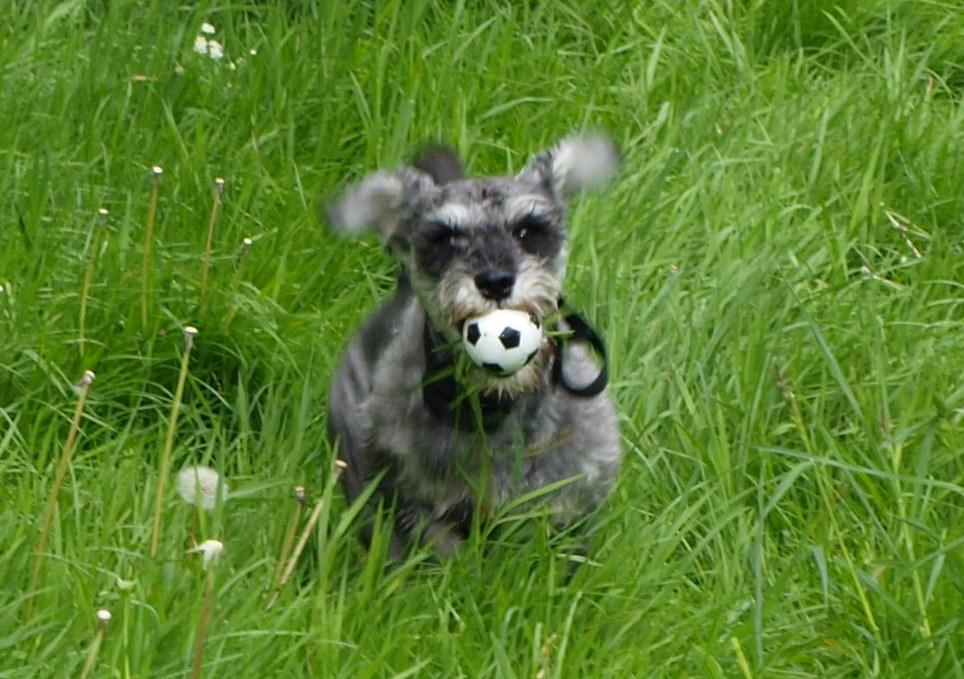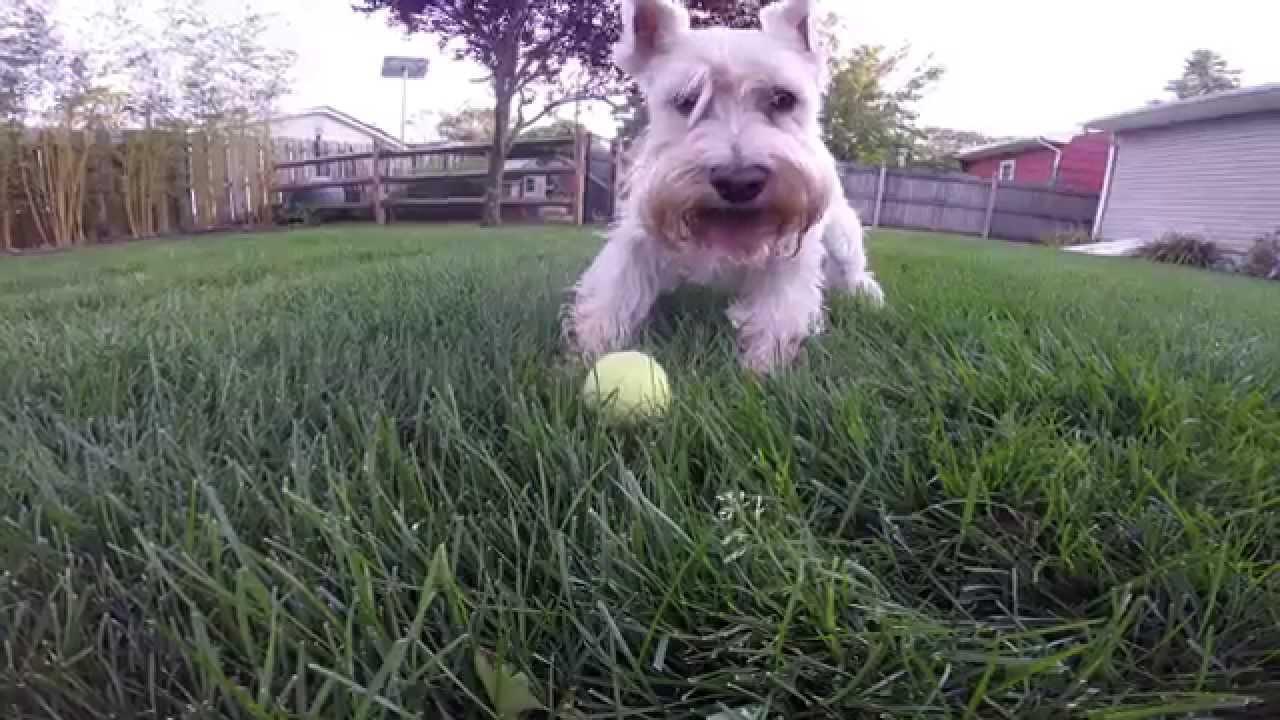The first image is the image on the left, the second image is the image on the right. Given the left and right images, does the statement "In one of the images there is a single dog that is holding something in its mouth and in the other there are two dogs playing." hold true? Answer yes or no. No. 